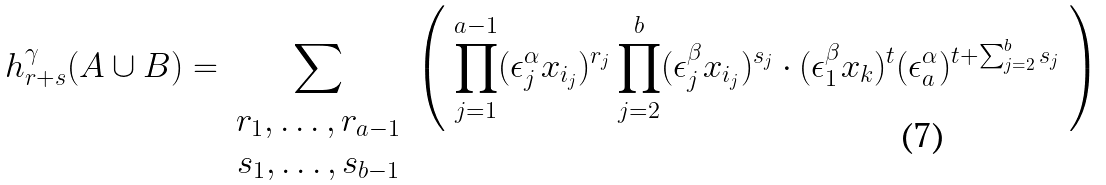<formula> <loc_0><loc_0><loc_500><loc_500>h ^ { \gamma } _ { r + s } ( A \cup B ) = \sum _ { \begin{array} { c } r _ { 1 } , \dots , r _ { a - 1 } \\ s _ { 1 } , \dots , s _ { b - 1 } \end{array} } \left ( \ \prod _ { j = 1 } ^ { a - 1 } ( \epsilon ^ { \alpha } _ { j } x _ { i _ { j } } ) ^ { r _ { j } } \prod _ { j = 2 } ^ { b } ( \epsilon ^ { \beta } _ { j } x _ { i _ { j } } ) ^ { s _ { j } } \cdot ( \epsilon ^ { \beta } _ { 1 } x _ { k } ) ^ { t } ( \epsilon ^ { \alpha } _ { a } ) ^ { t + \sum _ { j = 2 } ^ { b } s _ { j } } \ \right )</formula> 